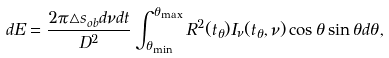Convert formula to latex. <formula><loc_0><loc_0><loc_500><loc_500>d E = \frac { 2 \pi \triangle s _ { o b } d \nu d t } { D ^ { 2 } } \int _ { \theta _ { \min } } ^ { \theta _ { \max } } R ^ { 2 } ( t _ { \theta } ) I _ { \nu } ( t _ { \theta } , \nu ) \cos \theta \sin \theta d \theta ,</formula> 